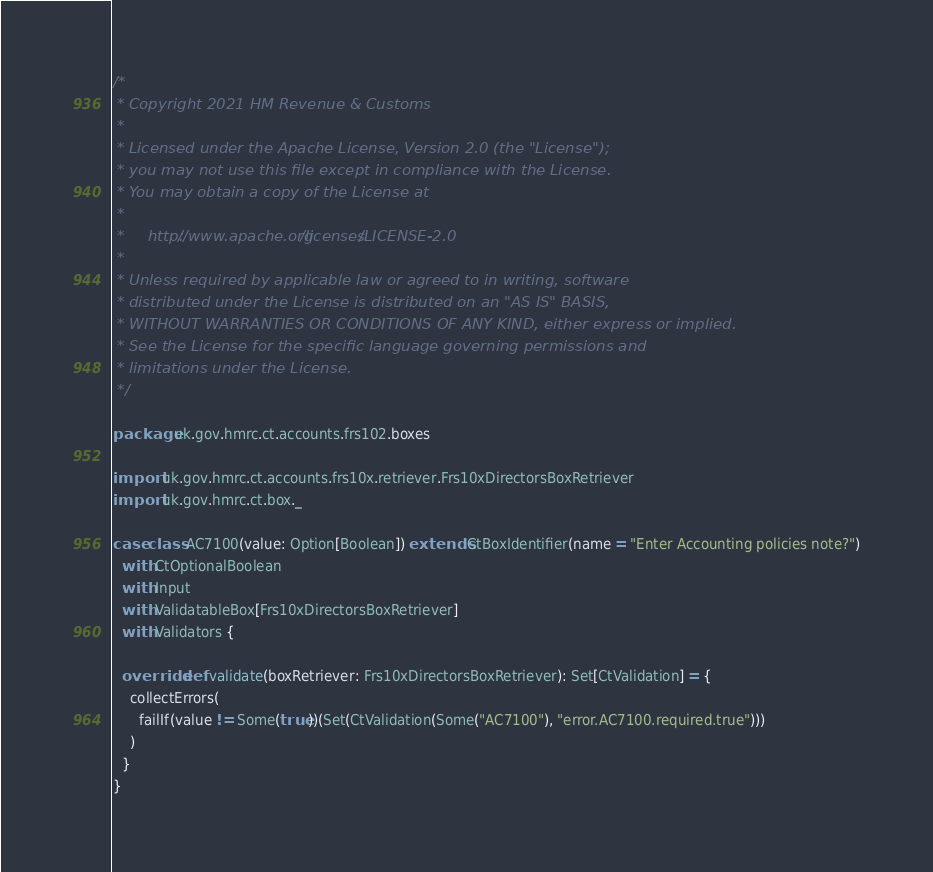Convert code to text. <code><loc_0><loc_0><loc_500><loc_500><_Scala_>/*
 * Copyright 2021 HM Revenue & Customs
 *
 * Licensed under the Apache License, Version 2.0 (the "License");
 * you may not use this file except in compliance with the License.
 * You may obtain a copy of the License at
 *
 *     http://www.apache.org/licenses/LICENSE-2.0
 *
 * Unless required by applicable law or agreed to in writing, software
 * distributed under the License is distributed on an "AS IS" BASIS,
 * WITHOUT WARRANTIES OR CONDITIONS OF ANY KIND, either express or implied.
 * See the License for the specific language governing permissions and
 * limitations under the License.
 */

package uk.gov.hmrc.ct.accounts.frs102.boxes

import uk.gov.hmrc.ct.accounts.frs10x.retriever.Frs10xDirectorsBoxRetriever
import uk.gov.hmrc.ct.box._

case class AC7100(value: Option[Boolean]) extends CtBoxIdentifier(name = "Enter Accounting policies note?")
  with CtOptionalBoolean
  with Input
  with ValidatableBox[Frs10xDirectorsBoxRetriever]
  with Validators {

  override def validate(boxRetriever: Frs10xDirectorsBoxRetriever): Set[CtValidation] = {
    collectErrors(
      failIf(value != Some(true))(Set(CtValidation(Some("AC7100"), "error.AC7100.required.true")))
    )
  }
}
</code> 